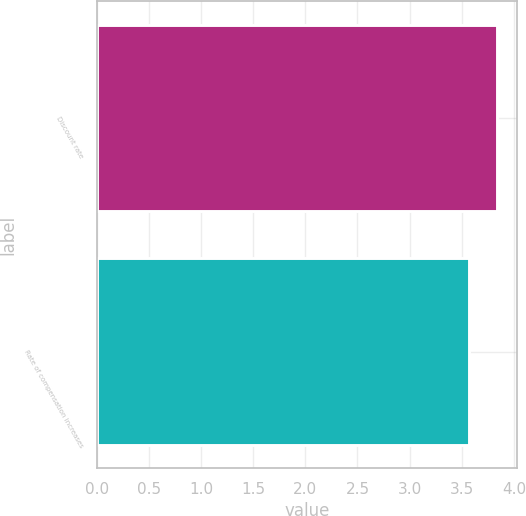Convert chart to OTSL. <chart><loc_0><loc_0><loc_500><loc_500><bar_chart><fcel>Discount rate<fcel>Rate of compensation increases<nl><fcel>3.84<fcel>3.57<nl></chart> 